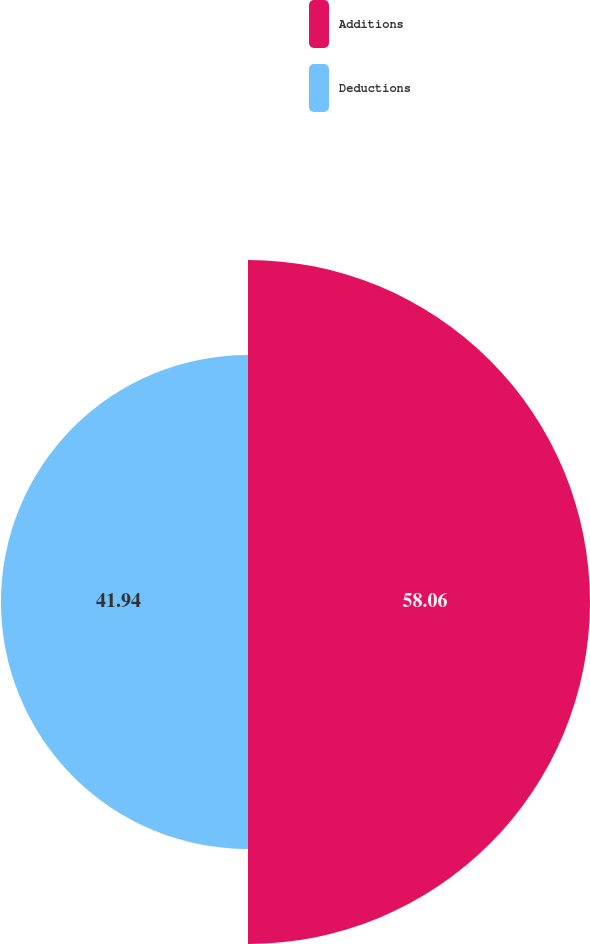Convert chart to OTSL. <chart><loc_0><loc_0><loc_500><loc_500><pie_chart><fcel>Additions<fcel>Deductions<nl><fcel>58.06%<fcel>41.94%<nl></chart> 